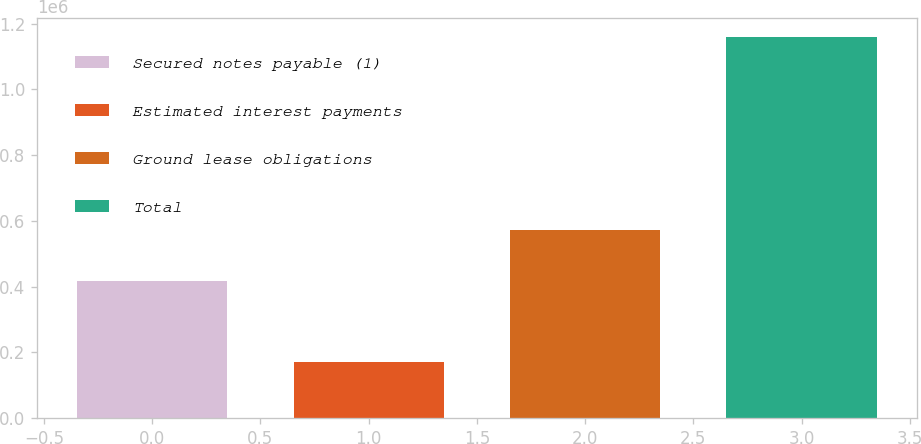Convert chart. <chart><loc_0><loc_0><loc_500><loc_500><bar_chart><fcel>Secured notes payable (1)<fcel>Estimated interest payments<fcel>Ground lease obligations<fcel>Total<nl><fcel>416748<fcel>170054<fcel>571972<fcel>1.15877e+06<nl></chart> 